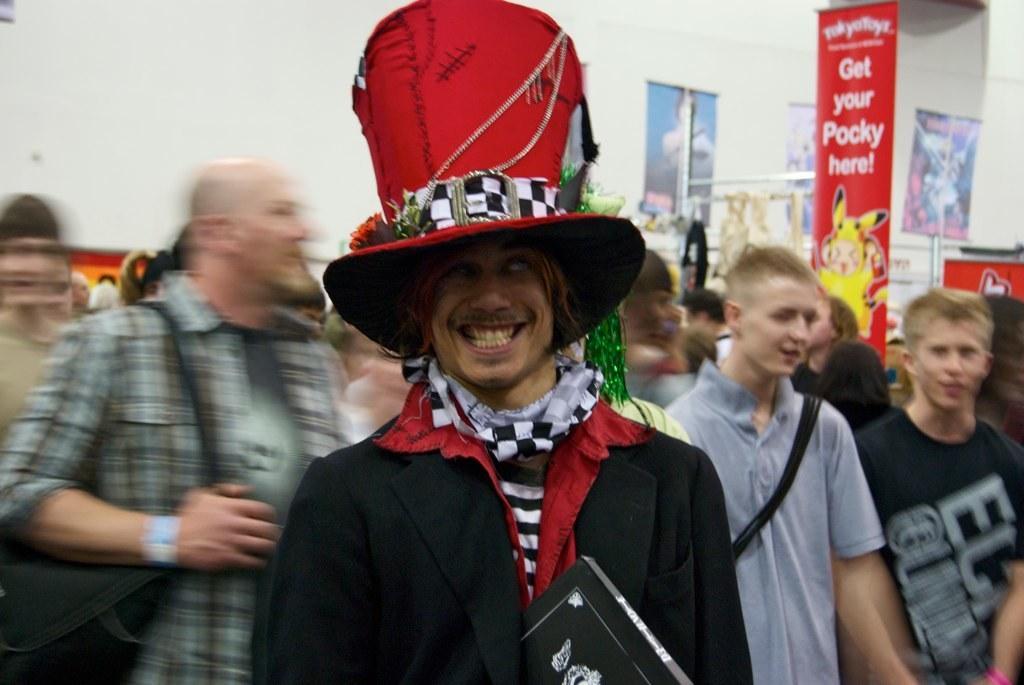Can you describe this image briefly? In the center of the image we can see a man is standing and wearing costume, hat and holding a book. In the background of the image we can see a group of people are standing and some of them are carrying bags and also we can see the boards, clothes, rods. At the top of the image we can see the wall. 